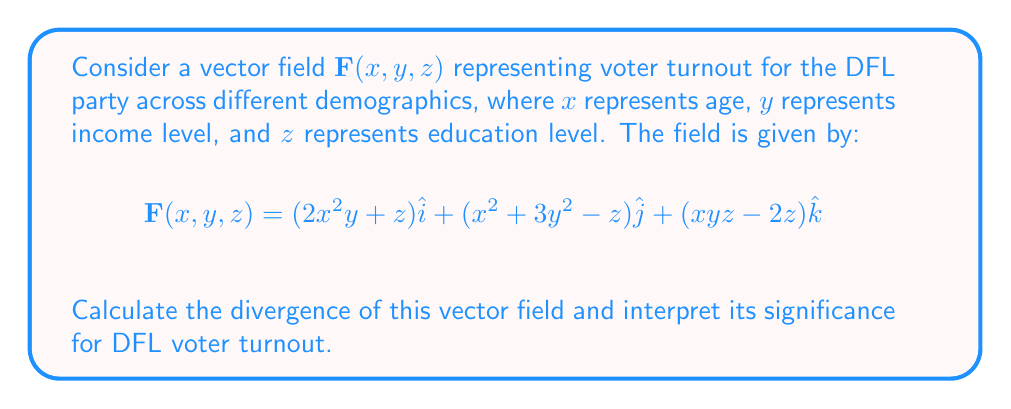Teach me how to tackle this problem. To calculate the divergence of the vector field, we need to find the sum of the partial derivatives of each component with respect to its corresponding variable. The divergence is given by:

$$\text{div}\mathbf{F} = \nabla \cdot \mathbf{F} = \frac{\partial F_x}{\partial x} + \frac{\partial F_y}{\partial y} + \frac{\partial F_z}{\partial z}$$

Let's calculate each partial derivative:

1. $\frac{\partial F_x}{\partial x} = \frac{\partial}{\partial x}(2x^2y + z) = 4xy$

2. $\frac{\partial F_y}{\partial y} = \frac{\partial}{\partial y}(x^2 + 3y^2 - z) = 6y$

3. $\frac{\partial F_z}{\partial z} = \frac{\partial}{\partial z}(xyz - 2z) = xy - 2$

Now, we sum these partial derivatives:

$$\text{div}\mathbf{F} = 4xy + 6y + xy - 2 = 5xy + 6y - 2$$

Interpretation for DFL voter turnout:
The divergence represents the rate at which voter turnout is changing with respect to age, income, and education levels. A positive divergence at a point $(x, y, z)$ indicates that voter turnout is increasing in that demographic, while a negative divergence suggests a decrease. The expression $5xy + 6y - 2$ shows that:

1. Voter turnout tends to increase more rapidly in demographics with higher age and income levels (positive $5xy$ term).
2. There's a consistent positive trend related to income level across all age groups (positive $6y$ term).
3. There's a small overall negative factor (-2) that slightly reduces turnout across all demographics.

This information can help the DFL party focus its efforts on demographics where turnout is lower or where there's potential for growth.
Answer: $\text{div}\mathbf{F} = 5xy + 6y - 2$ 